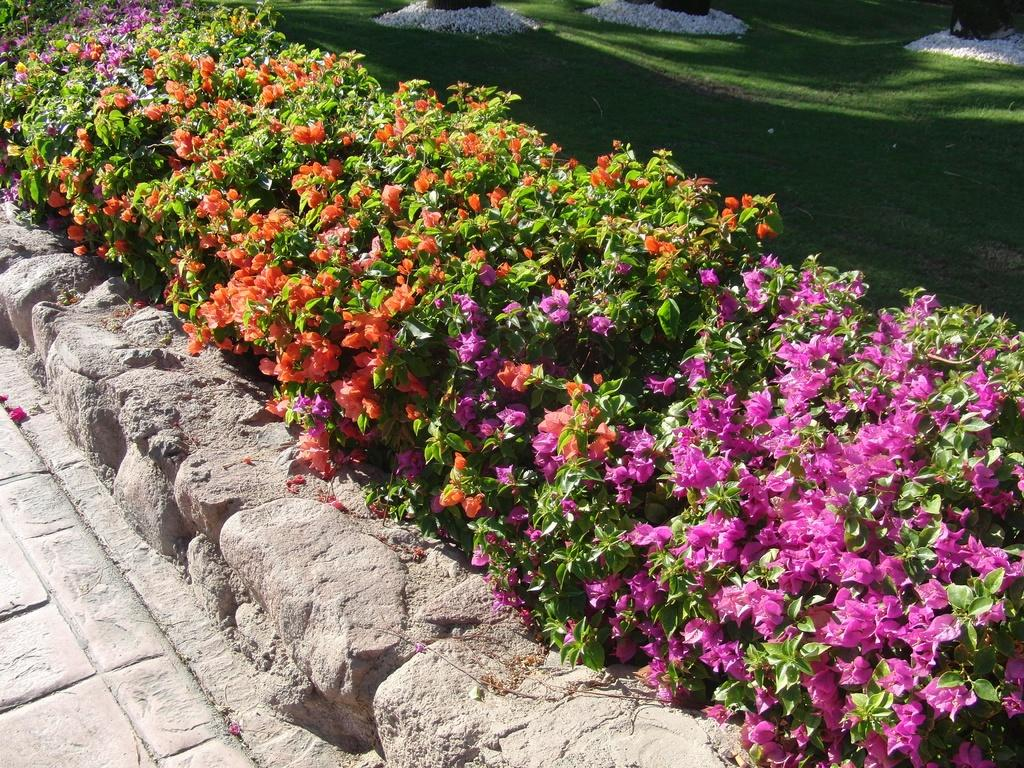What type of plants can be seen in the image? There are garden plants in the image. Are there any specific features of the garden plants? Yes, there are flowers among the garden plants. What type of ground cover is present in the image? There is grass in the image. What type of material is used for the pathway in the image? There are stones in the image, which form the pathway. Is there any structure made of stones in the image? Yes, there is a small stone wall in the image. What type of fuel is being used by the kitten in the image? There is no kitten present in the image, and therefore no fuel being used. 